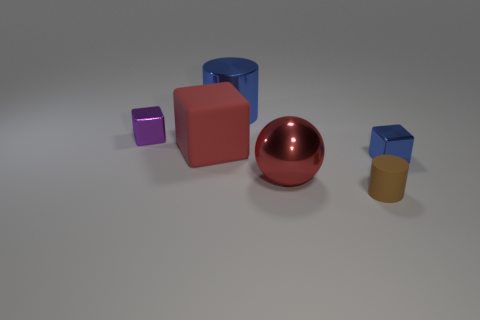Does the ball have the same color as the rubber cube?
Keep it short and to the point. Yes. Does the sphere have the same material as the purple cube?
Your response must be concise. Yes. Is the number of big blue cylinders less than the number of big purple metal cylinders?
Your response must be concise. No. Is the brown thing the same shape as the large blue thing?
Your answer should be very brief. Yes. What color is the tiny rubber thing?
Make the answer very short. Brown. How many other things are there of the same material as the small cylinder?
Make the answer very short. 1. What number of yellow objects are either tiny cylinders or cylinders?
Give a very brief answer. 0. There is a tiny thing that is to the right of the tiny matte thing; does it have the same shape as the small object that is behind the small blue block?
Offer a terse response. Yes. Do the big metal sphere and the matte thing behind the small blue thing have the same color?
Give a very brief answer. Yes. Does the tiny cube that is right of the red sphere have the same color as the large cylinder?
Provide a short and direct response. Yes. 